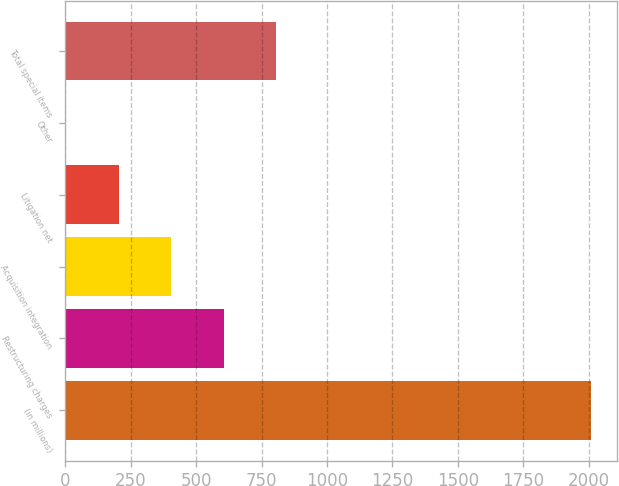<chart> <loc_0><loc_0><loc_500><loc_500><bar_chart><fcel>(in millions)<fcel>Restructuring charges<fcel>Acquisition integration<fcel>Litigation net<fcel>Other<fcel>Total special items<nl><fcel>2008<fcel>605.2<fcel>404.8<fcel>204.4<fcel>4<fcel>805.6<nl></chart> 